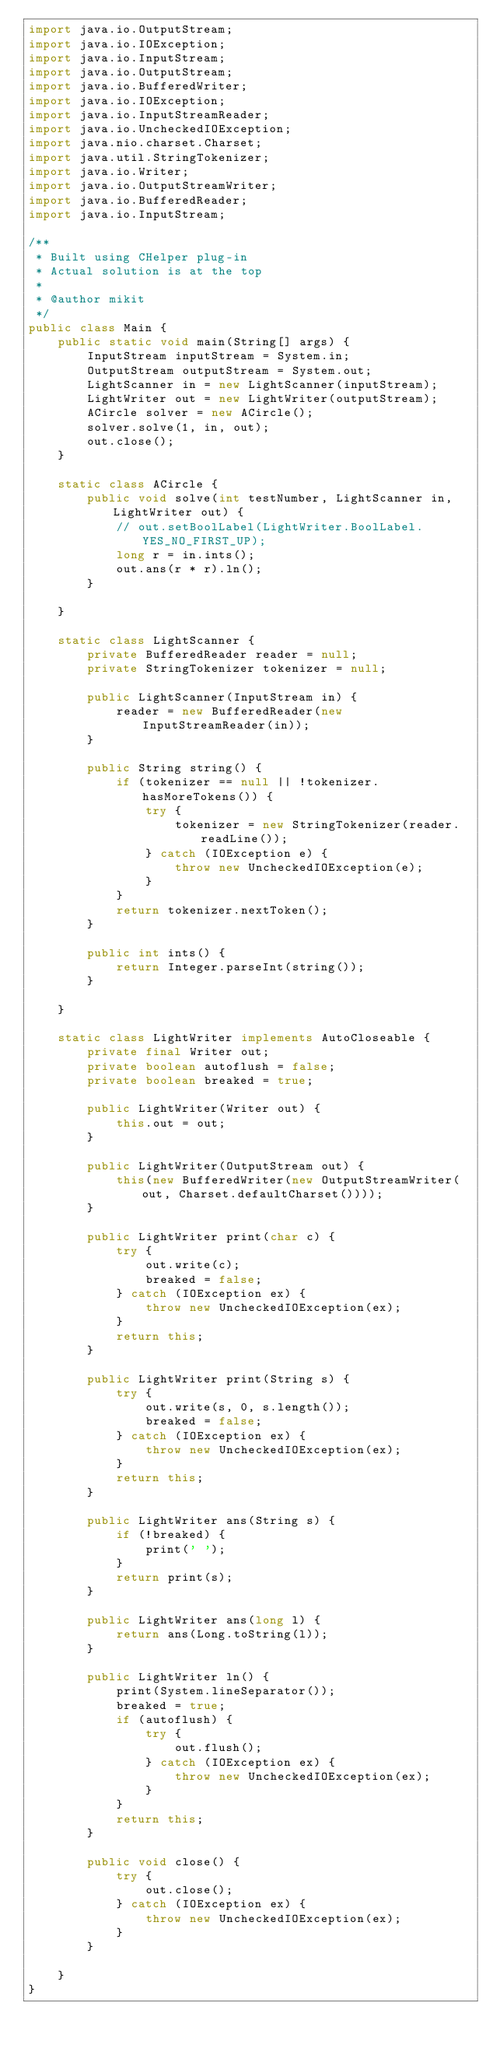Convert code to text. <code><loc_0><loc_0><loc_500><loc_500><_Java_>import java.io.OutputStream;
import java.io.IOException;
import java.io.InputStream;
import java.io.OutputStream;
import java.io.BufferedWriter;
import java.io.IOException;
import java.io.InputStreamReader;
import java.io.UncheckedIOException;
import java.nio.charset.Charset;
import java.util.StringTokenizer;
import java.io.Writer;
import java.io.OutputStreamWriter;
import java.io.BufferedReader;
import java.io.InputStream;

/**
 * Built using CHelper plug-in
 * Actual solution is at the top
 *
 * @author mikit
 */
public class Main {
    public static void main(String[] args) {
        InputStream inputStream = System.in;
        OutputStream outputStream = System.out;
        LightScanner in = new LightScanner(inputStream);
        LightWriter out = new LightWriter(outputStream);
        ACircle solver = new ACircle();
        solver.solve(1, in, out);
        out.close();
    }

    static class ACircle {
        public void solve(int testNumber, LightScanner in, LightWriter out) {
            // out.setBoolLabel(LightWriter.BoolLabel.YES_NO_FIRST_UP);
            long r = in.ints();
            out.ans(r * r).ln();
        }

    }

    static class LightScanner {
        private BufferedReader reader = null;
        private StringTokenizer tokenizer = null;

        public LightScanner(InputStream in) {
            reader = new BufferedReader(new InputStreamReader(in));
        }

        public String string() {
            if (tokenizer == null || !tokenizer.hasMoreTokens()) {
                try {
                    tokenizer = new StringTokenizer(reader.readLine());
                } catch (IOException e) {
                    throw new UncheckedIOException(e);
                }
            }
            return tokenizer.nextToken();
        }

        public int ints() {
            return Integer.parseInt(string());
        }

    }

    static class LightWriter implements AutoCloseable {
        private final Writer out;
        private boolean autoflush = false;
        private boolean breaked = true;

        public LightWriter(Writer out) {
            this.out = out;
        }

        public LightWriter(OutputStream out) {
            this(new BufferedWriter(new OutputStreamWriter(out, Charset.defaultCharset())));
        }

        public LightWriter print(char c) {
            try {
                out.write(c);
                breaked = false;
            } catch (IOException ex) {
                throw new UncheckedIOException(ex);
            }
            return this;
        }

        public LightWriter print(String s) {
            try {
                out.write(s, 0, s.length());
                breaked = false;
            } catch (IOException ex) {
                throw new UncheckedIOException(ex);
            }
            return this;
        }

        public LightWriter ans(String s) {
            if (!breaked) {
                print(' ');
            }
            return print(s);
        }

        public LightWriter ans(long l) {
            return ans(Long.toString(l));
        }

        public LightWriter ln() {
            print(System.lineSeparator());
            breaked = true;
            if (autoflush) {
                try {
                    out.flush();
                } catch (IOException ex) {
                    throw new UncheckedIOException(ex);
                }
            }
            return this;
        }

        public void close() {
            try {
                out.close();
            } catch (IOException ex) {
                throw new UncheckedIOException(ex);
            }
        }

    }
}

</code> 